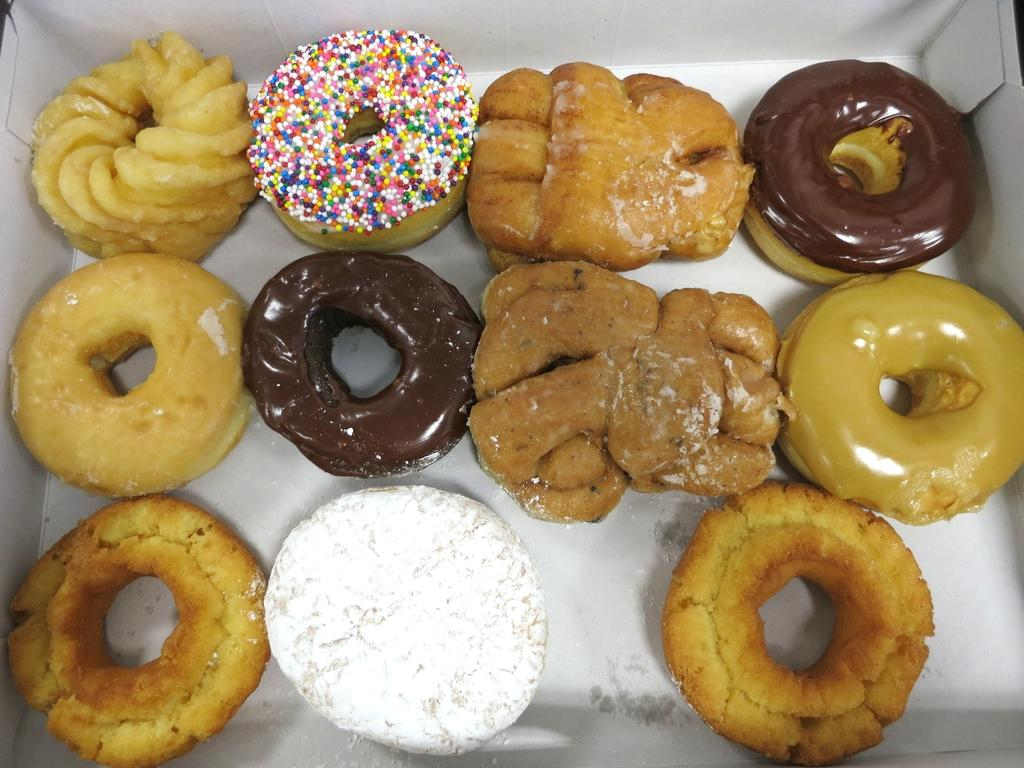What type of food is visible in the image? There is a group of donuts in the image. How are the donuts arranged or contained in the image? The donuts are placed in a box. What is the smell of the sun in the image? The sun is not present in the image, and therefore it does not have a smell. 